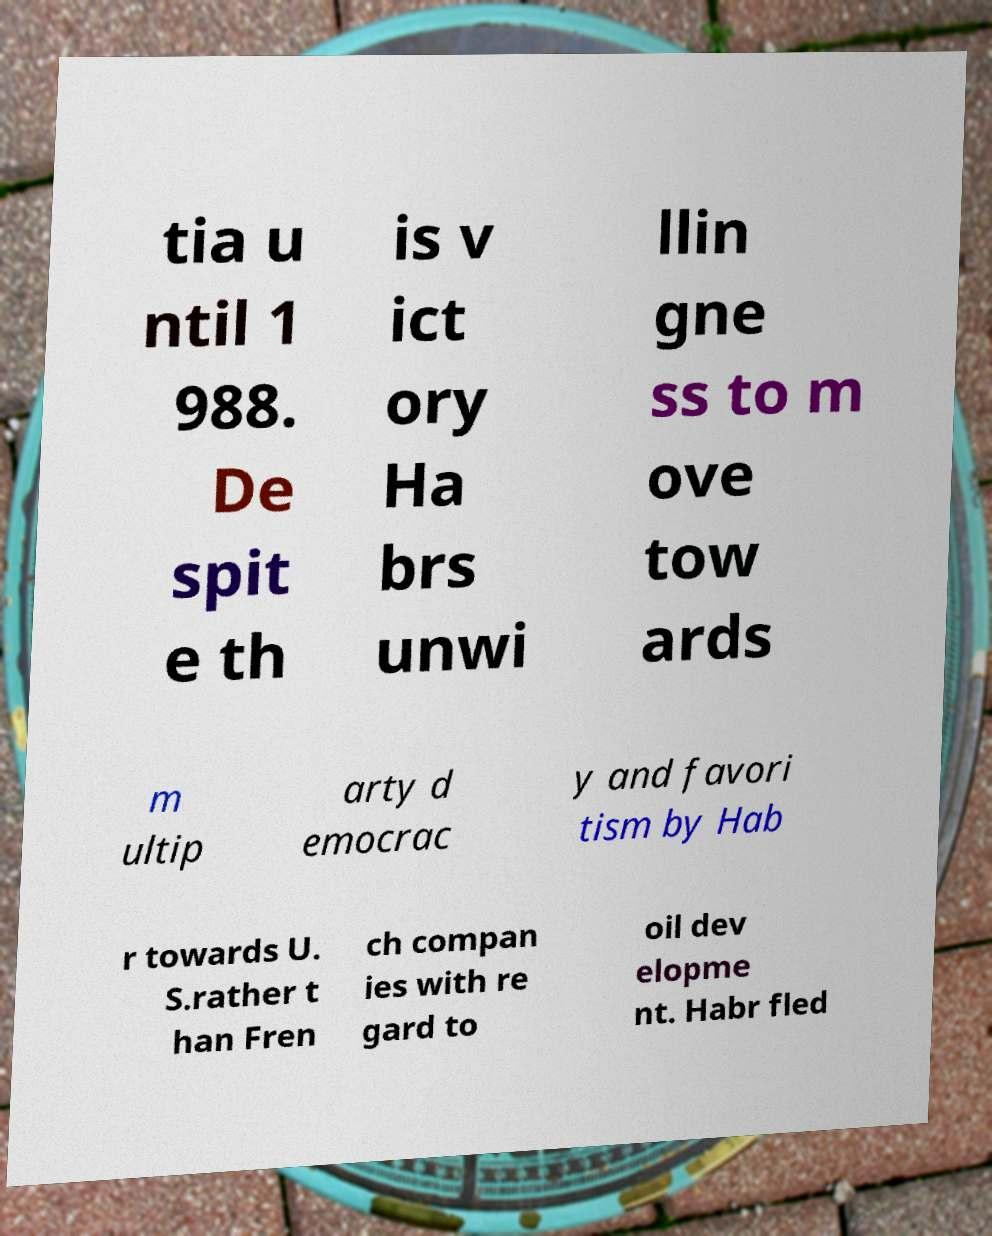There's text embedded in this image that I need extracted. Can you transcribe it verbatim? tia u ntil 1 988. De spit e th is v ict ory Ha brs unwi llin gne ss to m ove tow ards m ultip arty d emocrac y and favori tism by Hab r towards U. S.rather t han Fren ch compan ies with re gard to oil dev elopme nt. Habr fled 